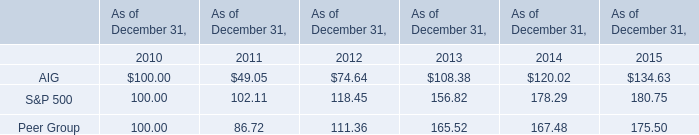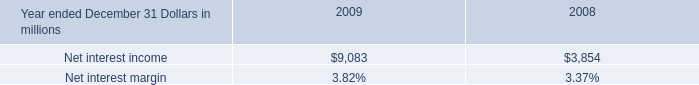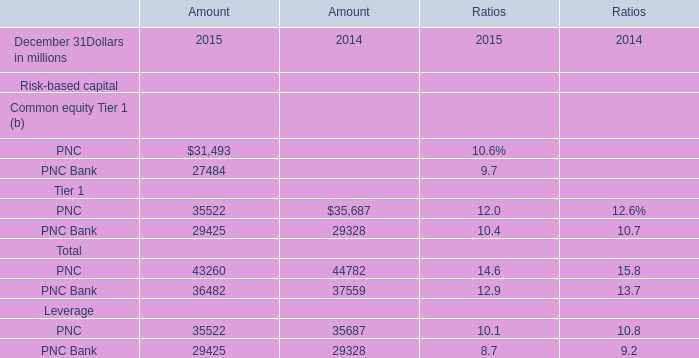what's the total amount of PNC of Amount 2015, and Net interest income of 2009 ? 
Computations: (31493.0 + 9083.0)
Answer: 40576.0. 